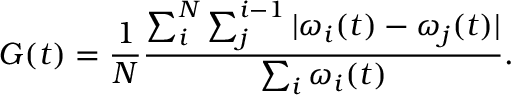<formula> <loc_0><loc_0><loc_500><loc_500>G ( t ) = \frac { 1 } { N } \frac { \sum _ { i } ^ { N } \sum _ { j } ^ { i - 1 } | \omega _ { i } ( t ) - \omega _ { j } ( t ) | } { \sum _ { i } \omega _ { i } ( t ) } .</formula> 